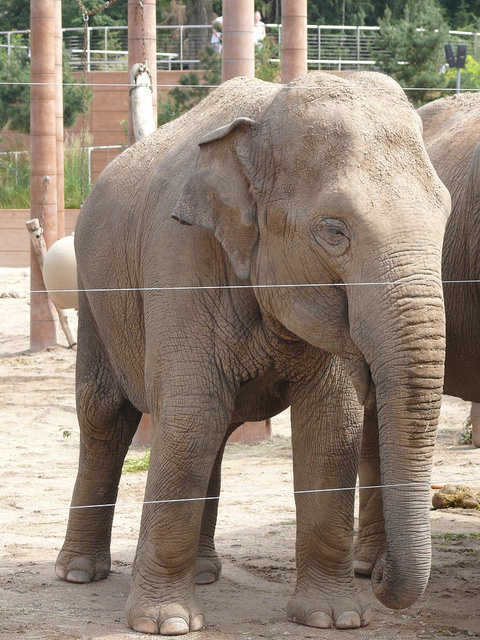Describe the objects in this image and their specific colors. I can see elephant in gray, maroon, and lightgray tones and elephant in gray, black, and darkgray tones in this image. 